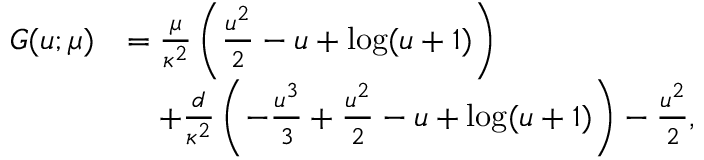<formula> <loc_0><loc_0><loc_500><loc_500>\begin{array} { r } { \begin{array} { r l } { G ( u ; \mu ) } & { = \frac { \mu } { \kappa ^ { 2 } } \left ( \frac { u ^ { 2 } } { 2 } - u + \log ( u + 1 ) \right ) } \\ & { \quad + \frac { d } { \kappa ^ { 2 } } \left ( - \frac { u ^ { 3 } } { 3 } + \frac { u ^ { 2 } } { 2 } - u + \log ( u + 1 ) \right ) - \frac { u ^ { 2 } } { 2 } , } \end{array} } \end{array}</formula> 